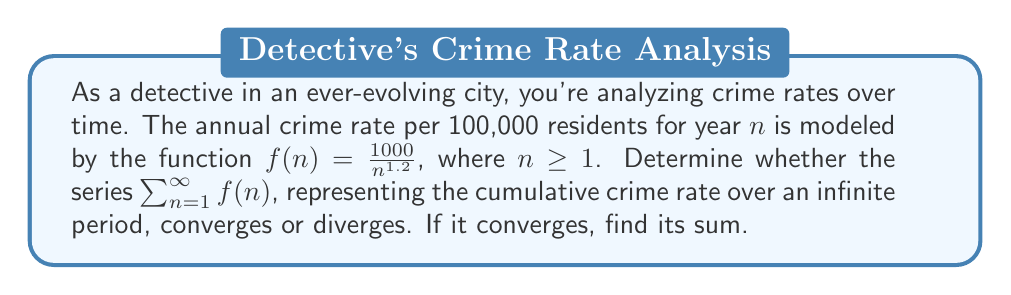Can you answer this question? To analyze the convergence of this series, we'll use the p-series test and the formula for the sum of a p-series.

1) First, let's identify the general term of our series:
   $$a_n = f(n) = \frac{1000}{n^{1.2}}$$

2) This is in the form of a p-series: $\frac{1}{n^p}$, where $p = 1.2$ and there's a constant factor of 1000.

3) For a p-series $\sum_{n=1}^{\infty} \frac{1}{n^p}$:
   - If $p > 1$, the series converges
   - If $p \leq 1$, the series diverges

4) In our case, $p = 1.2 > 1$, so the series converges.

5) For a convergent p-series, we can find the sum using the formula:
   $$S = \frac{1}{\zeta(p) - 1}$$
   where $\zeta(p)$ is the Riemann zeta function.

6) For $p = 1.2$, $\zeta(1.2) \approx 5.5915$

7) Therefore, the sum of our series is:
   $$S = 1000 \cdot \frac{1}{\zeta(1.2) - 1} \approx 1000 \cdot \frac{1}{4.5915} \approx 217.79$$

Thus, the series converges to approximately 217.79 crimes per 100,000 residents over an infinite period.
Answer: The series converges. The sum is approximately 217.79 crimes per 100,000 residents. 